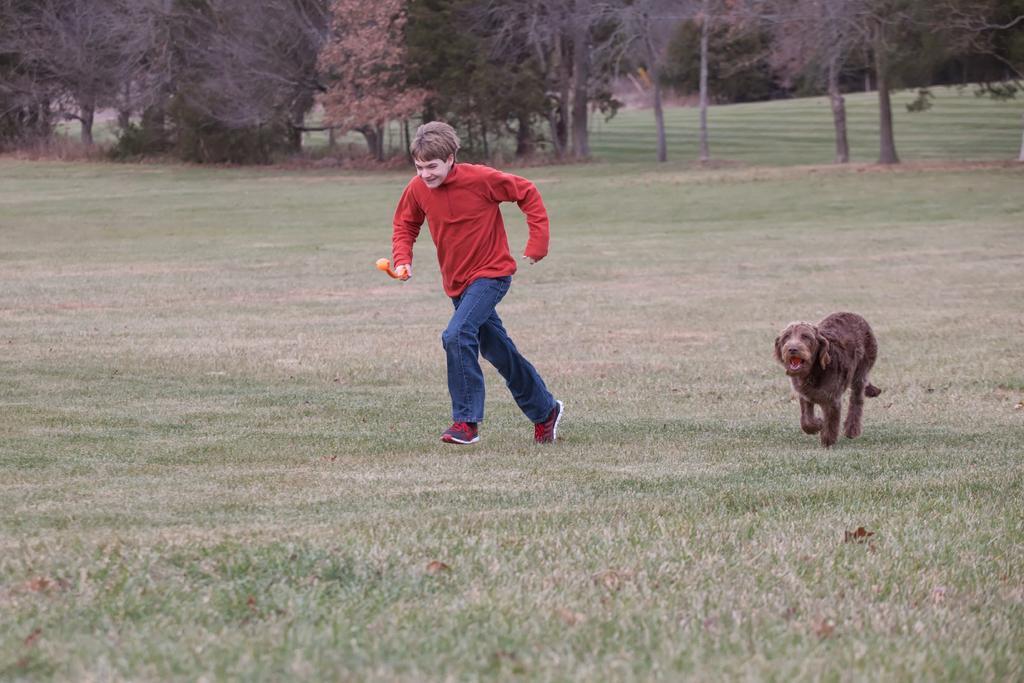Can you describe this image briefly? In this image there is a person wearing a red top is running on the grassland. Right side there is a dog running on grass land. Background there are few trees. 